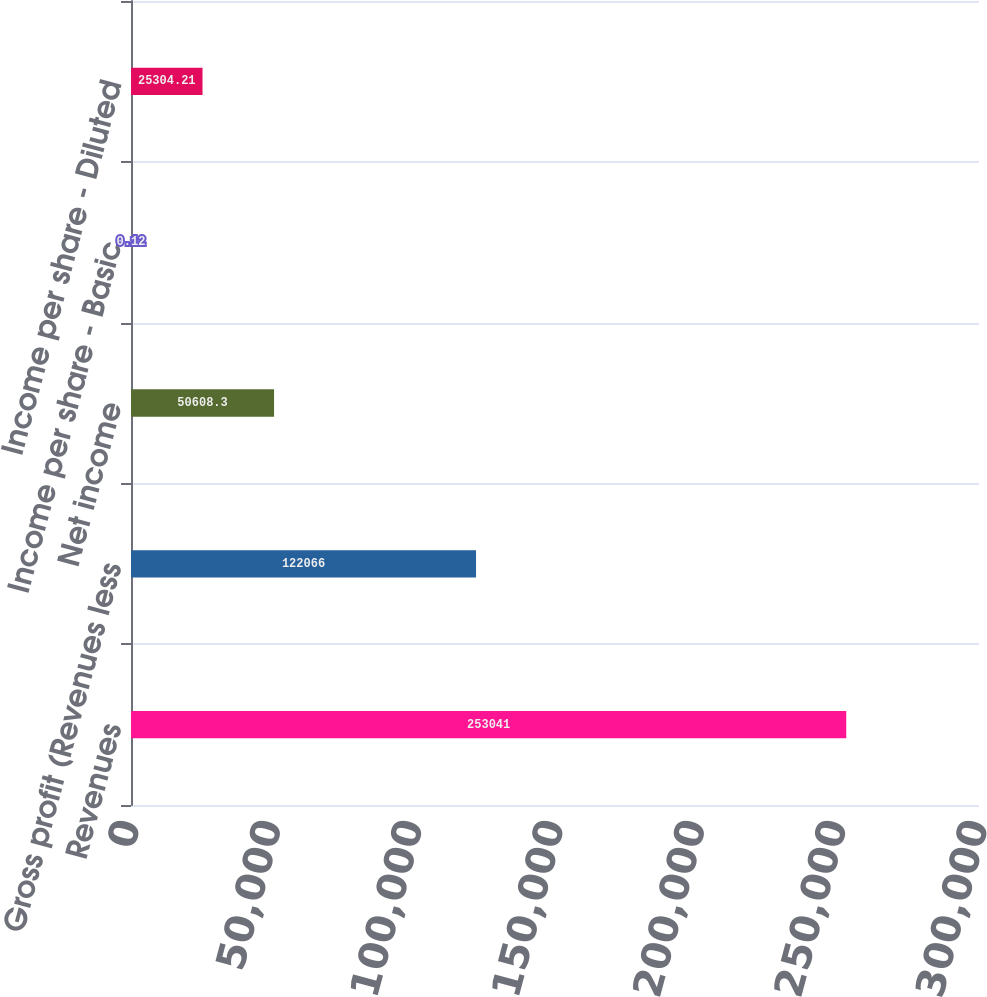Convert chart. <chart><loc_0><loc_0><loc_500><loc_500><bar_chart><fcel>Revenues<fcel>Gross profit (Revenues less<fcel>Net income<fcel>Income per share - Basic<fcel>Income per share - Diluted<nl><fcel>253041<fcel>122066<fcel>50608.3<fcel>0.12<fcel>25304.2<nl></chart> 